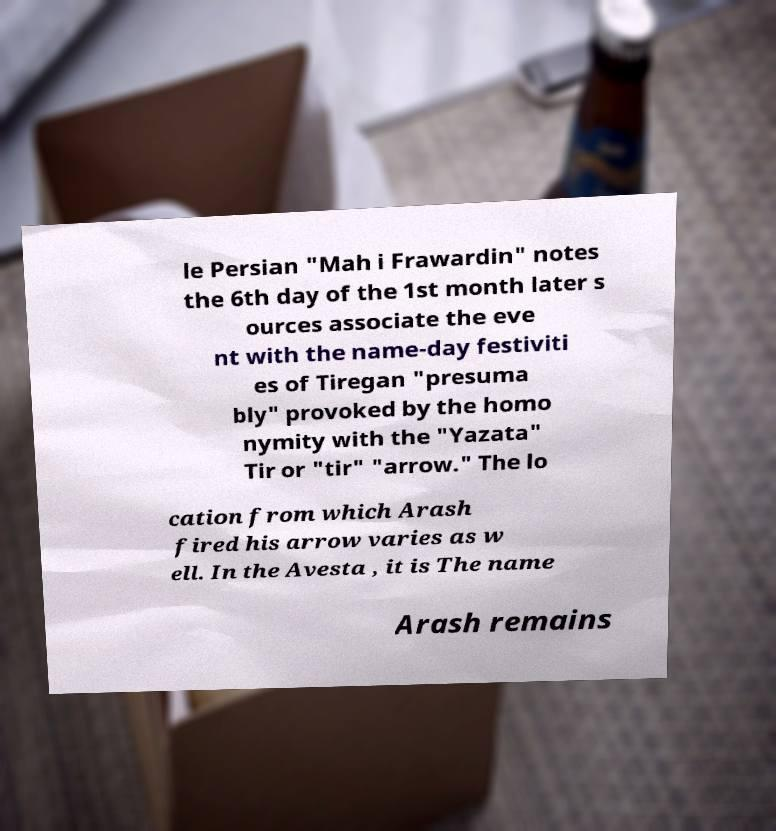Please identify and transcribe the text found in this image. le Persian "Mah i Frawardin" notes the 6th day of the 1st month later s ources associate the eve nt with the name-day festiviti es of Tiregan "presuma bly" provoked by the homo nymity with the "Yazata" Tir or "tir" "arrow." The lo cation from which Arash fired his arrow varies as w ell. In the Avesta , it is The name Arash remains 